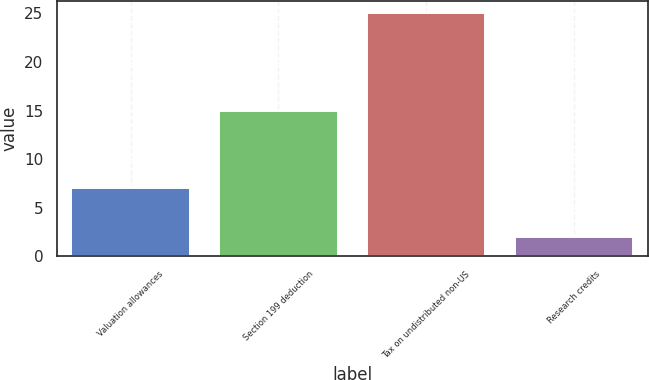Convert chart to OTSL. <chart><loc_0><loc_0><loc_500><loc_500><bar_chart><fcel>Valuation allowances<fcel>Section 199 deduction<fcel>Tax on undistributed non-US<fcel>Research credits<nl><fcel>7<fcel>15<fcel>25<fcel>2<nl></chart> 